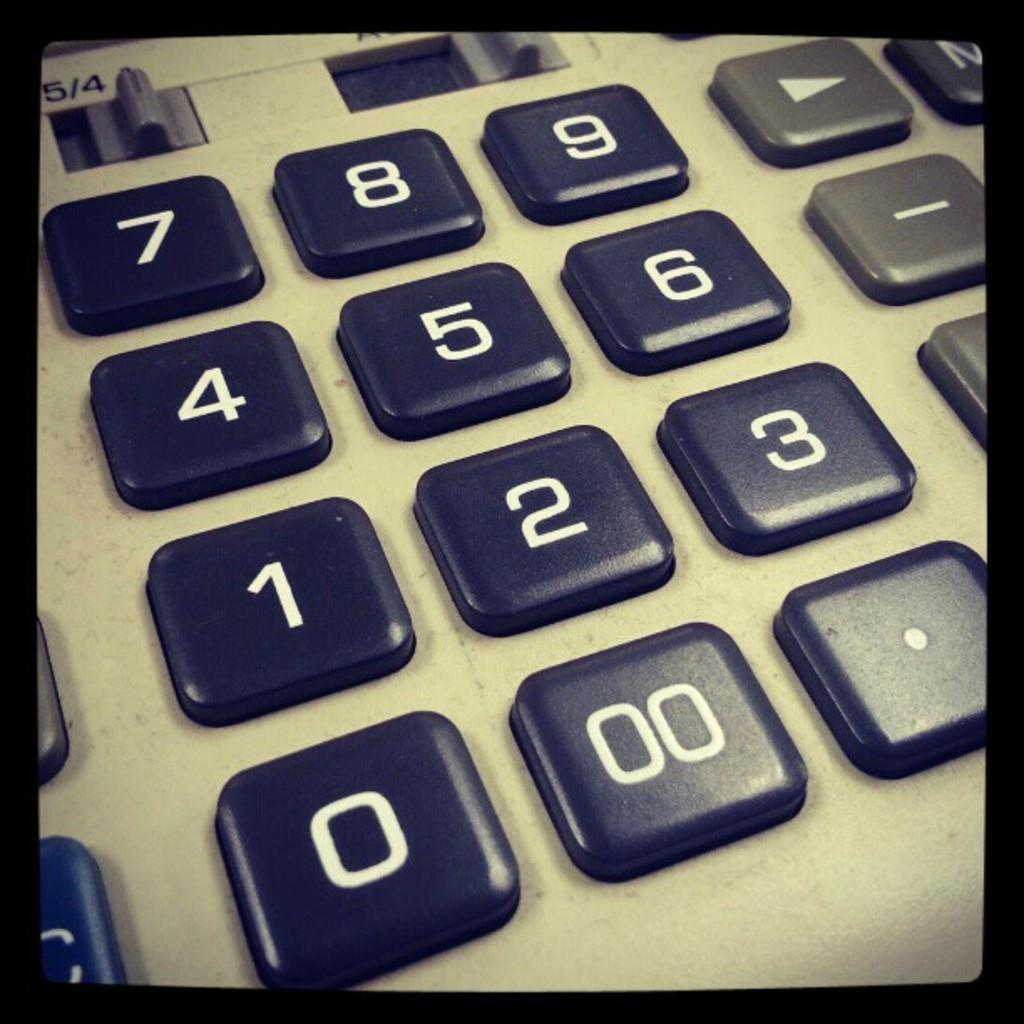<image>
Give a short and clear explanation of the subsequent image. A calculator that has a double zero button to the left of the decimal point. 